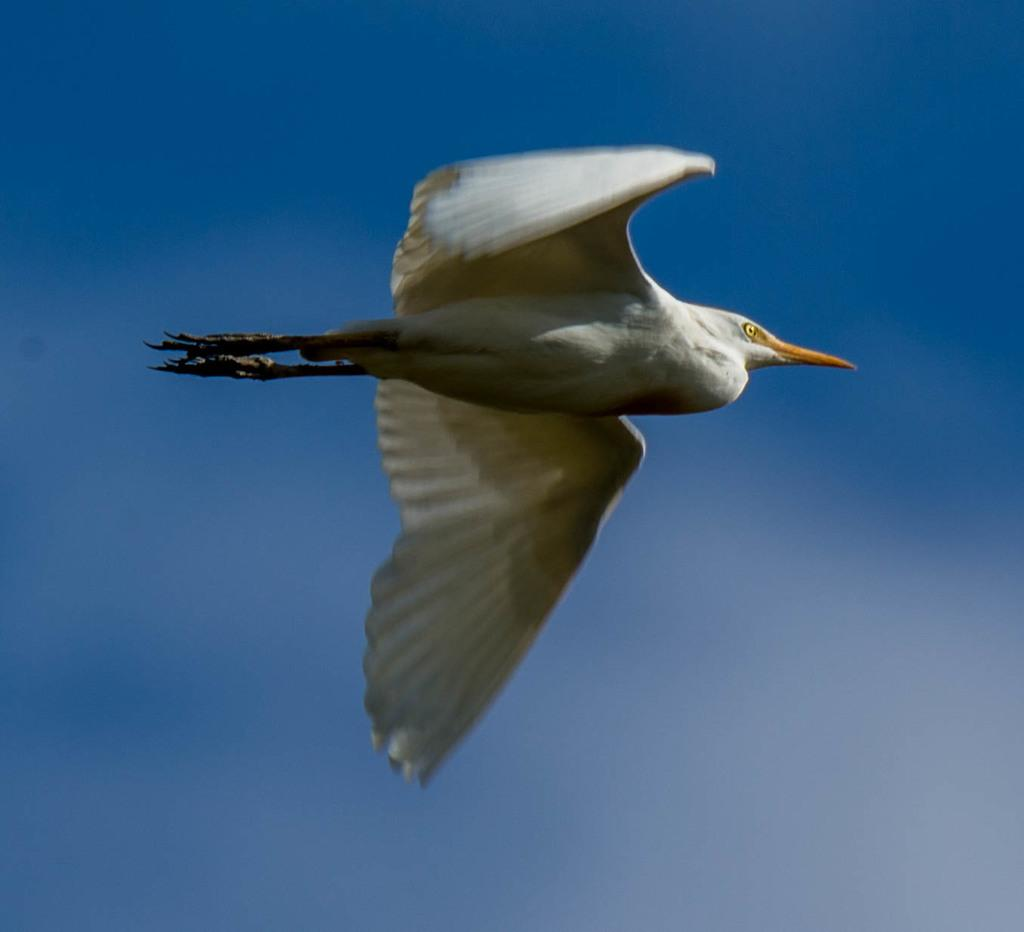What is present in the image? There is a bird in the image. What is the bird doing in the image? The bird is flying in the sky. Can you describe the appearance of the bird? The bird is white in color and has a long orange beak. What can be seen in the background of the image? The sky is visible in the background of the image. What is the color of the sky in the image? The sky is blue in color. Can you tell me how many crayons the bird is holding in its beak? There are no crayons present in the image, and the bird is not holding anything in its beak. 